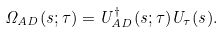Convert formula to latex. <formula><loc_0><loc_0><loc_500><loc_500>\Omega _ { A D } ( s ; \tau ) = U ^ { \dagger } _ { A D } ( s ; \tau ) U _ { \tau } ( s ) .</formula> 